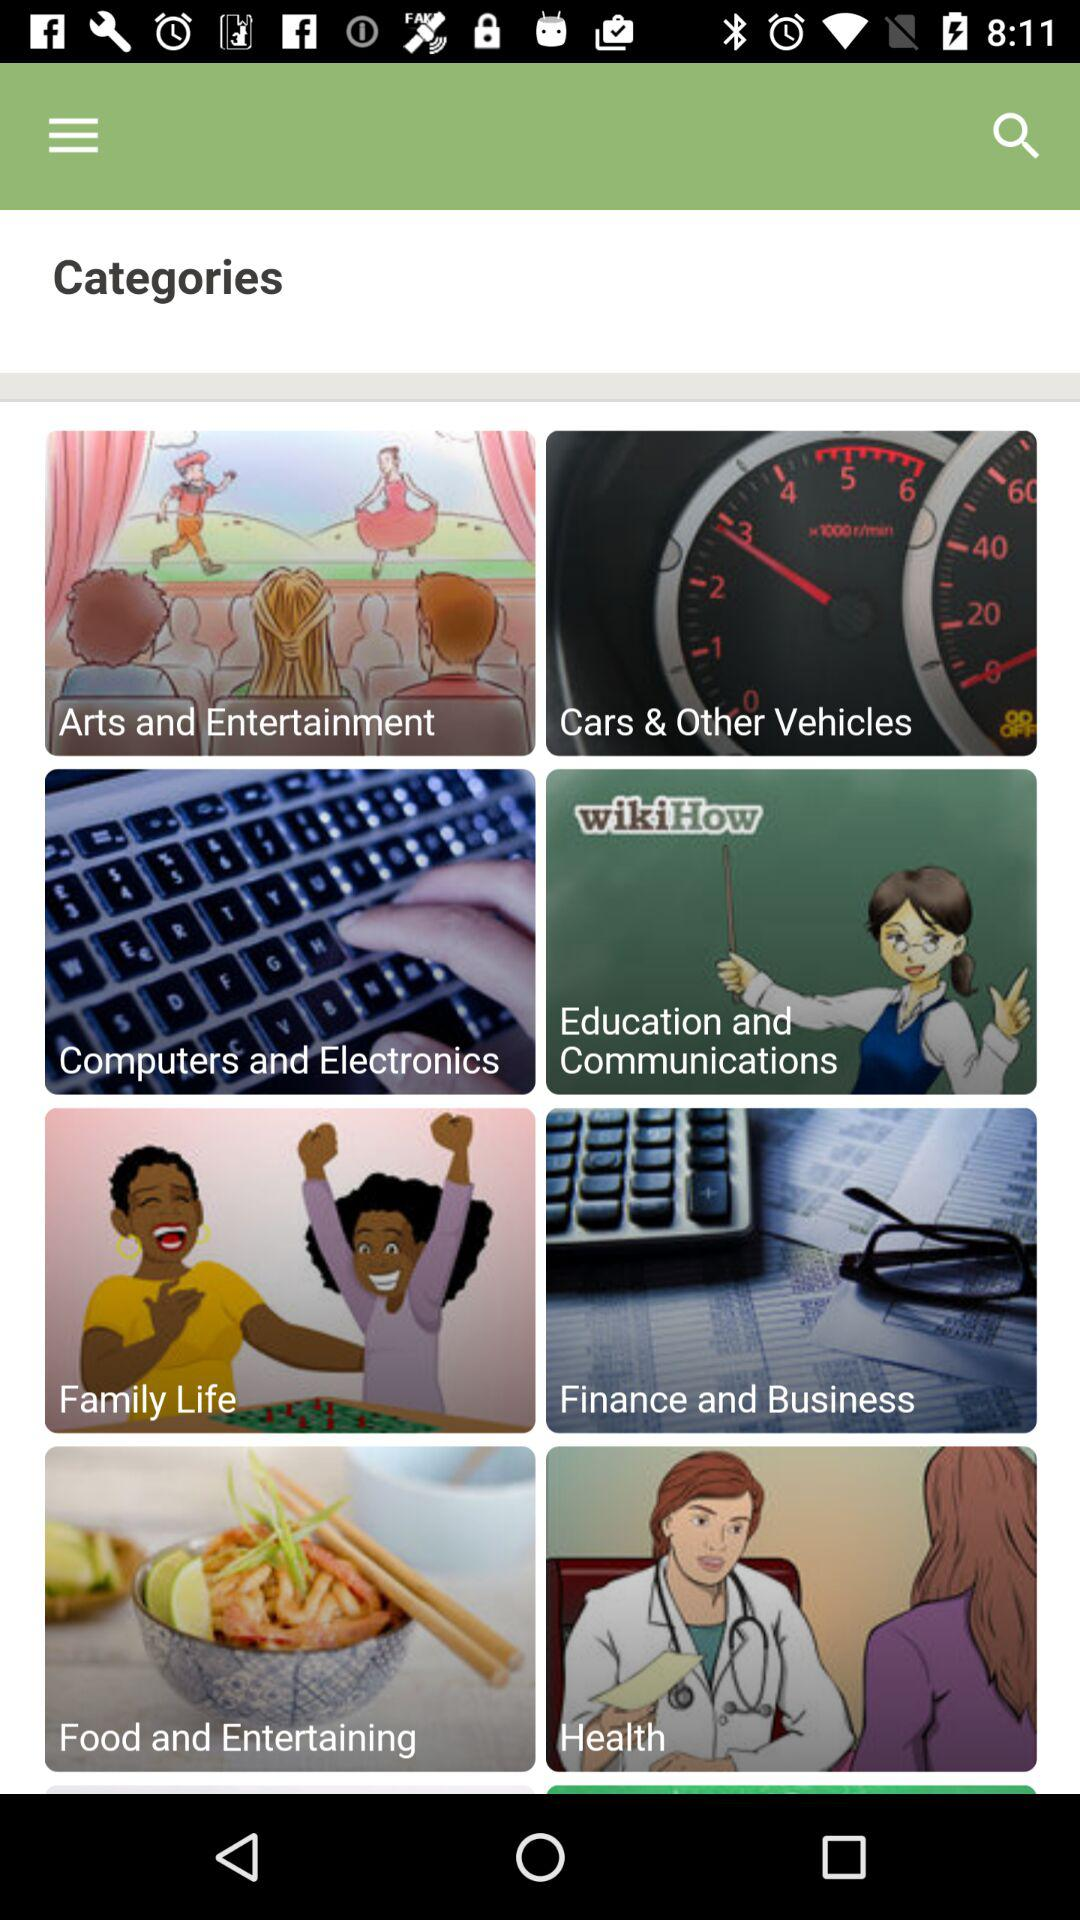What are the available options? The available options are "Arts and Entertainment", "Cars & Other Vehicles", "Computers and Electronics", "Education and Communications", "Family Life", "Finance and Business", "Food and Entertaining" and "Health". 